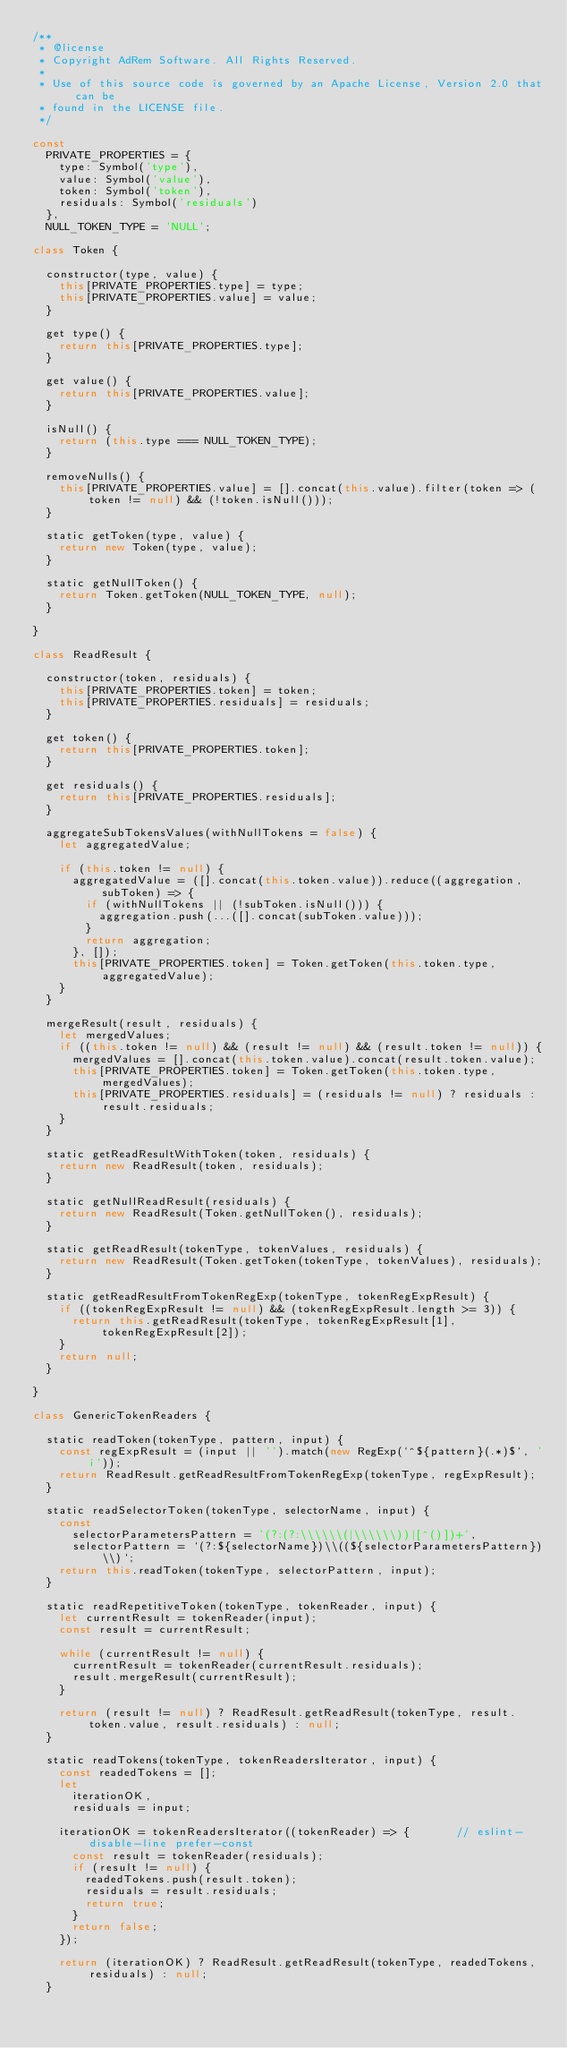<code> <loc_0><loc_0><loc_500><loc_500><_JavaScript_>/**
 * @license
 * Copyright AdRem Software. All Rights Reserved.
 *
 * Use of this source code is governed by an Apache License, Version 2.0 that can be
 * found in the LICENSE file.
 */

const
  PRIVATE_PROPERTIES = {
    type: Symbol('type'),
    value: Symbol('value'),
    token: Symbol('token'),
    residuals: Symbol('residuals')
  },
  NULL_TOKEN_TYPE = 'NULL';

class Token {

  constructor(type, value) {
    this[PRIVATE_PROPERTIES.type] = type;
    this[PRIVATE_PROPERTIES.value] = value;
  }

  get type() {
    return this[PRIVATE_PROPERTIES.type];
  }

  get value() {
    return this[PRIVATE_PROPERTIES.value];
  }

  isNull() {
    return (this.type === NULL_TOKEN_TYPE);
  }

  removeNulls() {
    this[PRIVATE_PROPERTIES.value] = [].concat(this.value).filter(token => (token != null) && (!token.isNull()));
  }

  static getToken(type, value) {
    return new Token(type, value);
  }

  static getNullToken() {
    return Token.getToken(NULL_TOKEN_TYPE, null);
  }

}

class ReadResult {

  constructor(token, residuals) {
    this[PRIVATE_PROPERTIES.token] = token;
    this[PRIVATE_PROPERTIES.residuals] = residuals;
  }

  get token() {
    return this[PRIVATE_PROPERTIES.token];
  }

  get residuals() {
    return this[PRIVATE_PROPERTIES.residuals];
  }

  aggregateSubTokensValues(withNullTokens = false) {
    let aggregatedValue;

    if (this.token != null) {
      aggregatedValue = ([].concat(this.token.value)).reduce((aggregation, subToken) => {
        if (withNullTokens || (!subToken.isNull())) {
          aggregation.push(...([].concat(subToken.value)));
        }
        return aggregation;
      }, []);
      this[PRIVATE_PROPERTIES.token] = Token.getToken(this.token.type, aggregatedValue);
    }
  }

  mergeResult(result, residuals) {
    let mergedValues;
    if ((this.token != null) && (result != null) && (result.token != null)) {
      mergedValues = [].concat(this.token.value).concat(result.token.value);
      this[PRIVATE_PROPERTIES.token] = Token.getToken(this.token.type, mergedValues);
      this[PRIVATE_PROPERTIES.residuals] = (residuals != null) ? residuals : result.residuals;
    }
  }

  static getReadResultWithToken(token, residuals) {
    return new ReadResult(token, residuals);
  }

  static getNullReadResult(residuals) {
    return new ReadResult(Token.getNullToken(), residuals);
  }

  static getReadResult(tokenType, tokenValues, residuals) {
    return new ReadResult(Token.getToken(tokenType, tokenValues), residuals);
  }

  static getReadResultFromTokenRegExp(tokenType, tokenRegExpResult) {
    if ((tokenRegExpResult != null) && (tokenRegExpResult.length >= 3)) {
      return this.getReadResult(tokenType, tokenRegExpResult[1], tokenRegExpResult[2]);
    }
    return null;
  }

}

class GenericTokenReaders {

  static readToken(tokenType, pattern, input) {
    const regExpResult = (input || '').match(new RegExp(`^${pattern}(.*)$`, 'i'));
    return ReadResult.getReadResultFromTokenRegExp(tokenType, regExpResult);
  }

  static readSelectorToken(tokenType, selectorName, input) {
    const
      selectorParametersPattern = '(?:(?:\\\\\\(|\\\\\\))|[^()])+',
      selectorPattern = `(?:${selectorName})\\((${selectorParametersPattern})\\)`;
    return this.readToken(tokenType, selectorPattern, input);
  }

  static readRepetitiveToken(tokenType, tokenReader, input) {
    let currentResult = tokenReader(input);
    const result = currentResult;

    while (currentResult != null) {
      currentResult = tokenReader(currentResult.residuals);
      result.mergeResult(currentResult);
    }

    return (result != null) ? ReadResult.getReadResult(tokenType, result.token.value, result.residuals) : null;
  }

  static readTokens(tokenType, tokenReadersIterator, input) {
    const readedTokens = [];
    let
      iterationOK,
      residuals = input;

    iterationOK = tokenReadersIterator((tokenReader) => {       // eslint-disable-line prefer-const
      const result = tokenReader(residuals);
      if (result != null) {
        readedTokens.push(result.token);
        residuals = result.residuals;
        return true;
      }
      return false;
    });

    return (iterationOK) ? ReadResult.getReadResult(tokenType, readedTokens, residuals) : null;
  }
</code> 